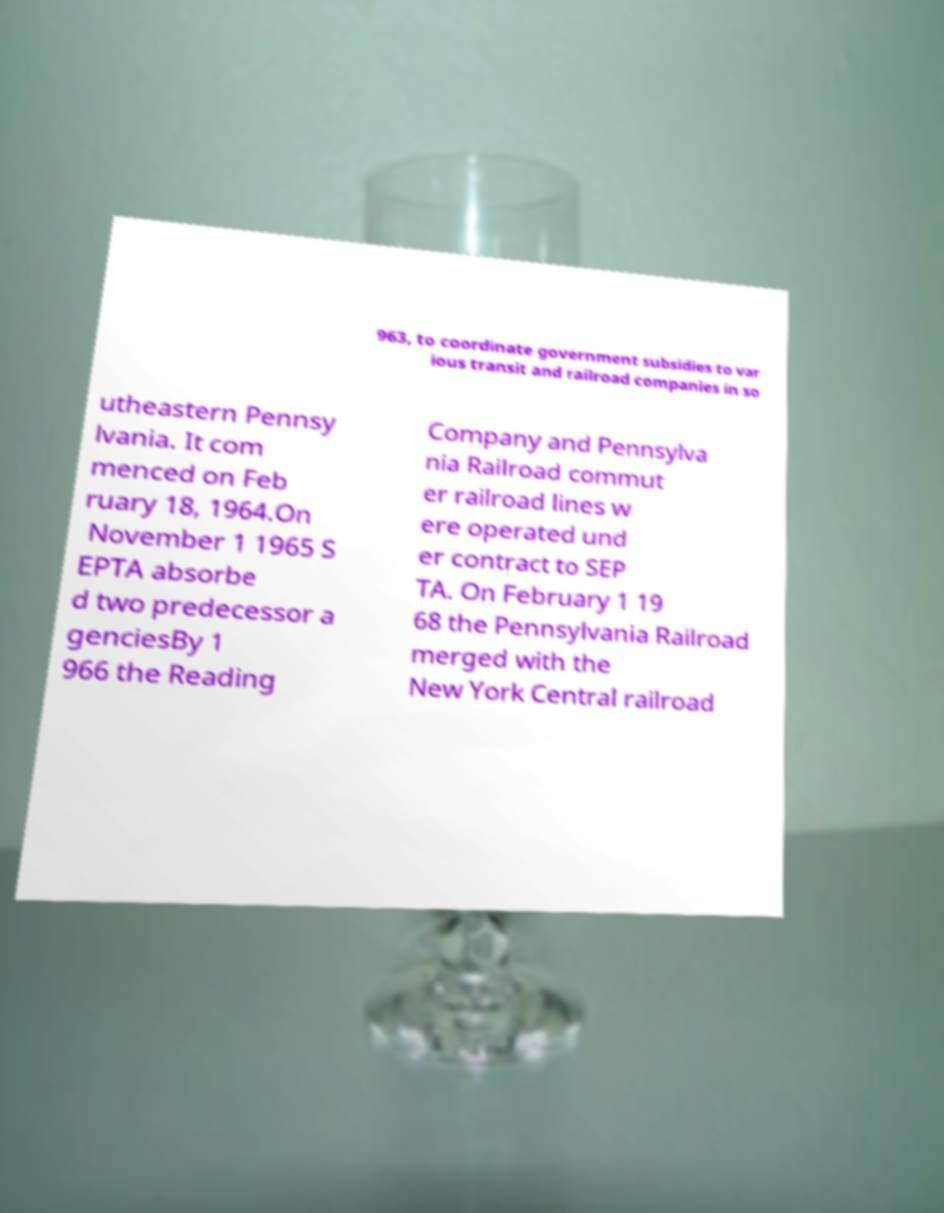Can you accurately transcribe the text from the provided image for me? 963, to coordinate government subsidies to var ious transit and railroad companies in so utheastern Pennsy lvania. It com menced on Feb ruary 18, 1964.On November 1 1965 S EPTA absorbe d two predecessor a genciesBy 1 966 the Reading Company and Pennsylva nia Railroad commut er railroad lines w ere operated und er contract to SEP TA. On February 1 19 68 the Pennsylvania Railroad merged with the New York Central railroad 